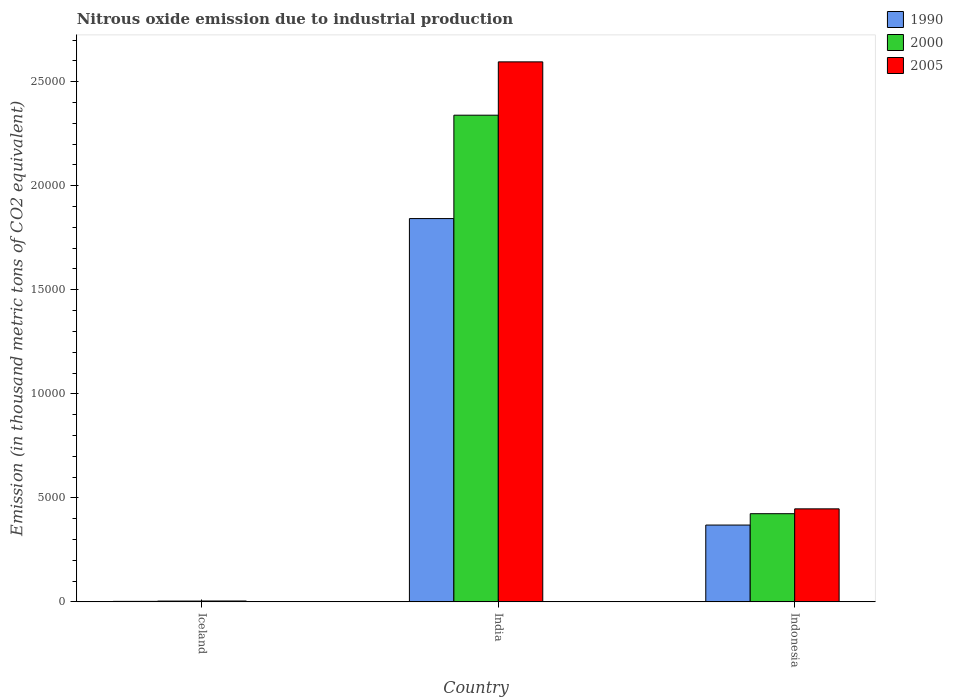How many different coloured bars are there?
Offer a terse response. 3. How many bars are there on the 3rd tick from the right?
Ensure brevity in your answer.  3. What is the amount of nitrous oxide emitted in 2005 in India?
Offer a terse response. 2.60e+04. Across all countries, what is the maximum amount of nitrous oxide emitted in 2000?
Make the answer very short. 2.34e+04. Across all countries, what is the minimum amount of nitrous oxide emitted in 2000?
Keep it short and to the point. 38.6. In which country was the amount of nitrous oxide emitted in 2000 maximum?
Your response must be concise. India. What is the total amount of nitrous oxide emitted in 2005 in the graph?
Offer a very short reply. 3.05e+04. What is the difference between the amount of nitrous oxide emitted in 2005 in Iceland and that in India?
Your response must be concise. -2.59e+04. What is the difference between the amount of nitrous oxide emitted in 2005 in India and the amount of nitrous oxide emitted in 1990 in Indonesia?
Make the answer very short. 2.23e+04. What is the average amount of nitrous oxide emitted in 2000 per country?
Your answer should be very brief. 9222.6. What is the difference between the amount of nitrous oxide emitted of/in 2000 and amount of nitrous oxide emitted of/in 1990 in India?
Keep it short and to the point. 4968.5. In how many countries, is the amount of nitrous oxide emitted in 2005 greater than 2000 thousand metric tons?
Give a very brief answer. 2. What is the ratio of the amount of nitrous oxide emitted in 2005 in Iceland to that in Indonesia?
Ensure brevity in your answer.  0.01. Is the amount of nitrous oxide emitted in 2005 in Iceland less than that in India?
Keep it short and to the point. Yes. What is the difference between the highest and the second highest amount of nitrous oxide emitted in 1990?
Keep it short and to the point. -3667.8. What is the difference between the highest and the lowest amount of nitrous oxide emitted in 1990?
Your answer should be compact. 1.84e+04. What does the 3rd bar from the left in Indonesia represents?
Make the answer very short. 2005. What is the difference between two consecutive major ticks on the Y-axis?
Your answer should be compact. 5000. Does the graph contain any zero values?
Keep it short and to the point. No. Where does the legend appear in the graph?
Give a very brief answer. Top right. What is the title of the graph?
Provide a succinct answer. Nitrous oxide emission due to industrial production. Does "1974" appear as one of the legend labels in the graph?
Provide a short and direct response. No. What is the label or title of the Y-axis?
Keep it short and to the point. Emission (in thousand metric tons of CO2 equivalent). What is the Emission (in thousand metric tons of CO2 equivalent) in 1990 in Iceland?
Ensure brevity in your answer.  24.6. What is the Emission (in thousand metric tons of CO2 equivalent) of 2000 in Iceland?
Ensure brevity in your answer.  38.6. What is the Emission (in thousand metric tons of CO2 equivalent) in 2005 in Iceland?
Ensure brevity in your answer.  42.1. What is the Emission (in thousand metric tons of CO2 equivalent) in 1990 in India?
Ensure brevity in your answer.  1.84e+04. What is the Emission (in thousand metric tons of CO2 equivalent) of 2000 in India?
Your answer should be compact. 2.34e+04. What is the Emission (in thousand metric tons of CO2 equivalent) in 2005 in India?
Offer a very short reply. 2.60e+04. What is the Emission (in thousand metric tons of CO2 equivalent) of 1990 in Indonesia?
Your answer should be compact. 3692.4. What is the Emission (in thousand metric tons of CO2 equivalent) of 2000 in Indonesia?
Ensure brevity in your answer.  4237.9. What is the Emission (in thousand metric tons of CO2 equivalent) in 2005 in Indonesia?
Keep it short and to the point. 4470.7. Across all countries, what is the maximum Emission (in thousand metric tons of CO2 equivalent) of 1990?
Give a very brief answer. 1.84e+04. Across all countries, what is the maximum Emission (in thousand metric tons of CO2 equivalent) in 2000?
Ensure brevity in your answer.  2.34e+04. Across all countries, what is the maximum Emission (in thousand metric tons of CO2 equivalent) of 2005?
Your answer should be compact. 2.60e+04. Across all countries, what is the minimum Emission (in thousand metric tons of CO2 equivalent) in 1990?
Your answer should be compact. 24.6. Across all countries, what is the minimum Emission (in thousand metric tons of CO2 equivalent) in 2000?
Provide a short and direct response. 38.6. Across all countries, what is the minimum Emission (in thousand metric tons of CO2 equivalent) in 2005?
Make the answer very short. 42.1. What is the total Emission (in thousand metric tons of CO2 equivalent) of 1990 in the graph?
Provide a succinct answer. 2.21e+04. What is the total Emission (in thousand metric tons of CO2 equivalent) of 2000 in the graph?
Your answer should be very brief. 2.77e+04. What is the total Emission (in thousand metric tons of CO2 equivalent) of 2005 in the graph?
Your answer should be very brief. 3.05e+04. What is the difference between the Emission (in thousand metric tons of CO2 equivalent) of 1990 in Iceland and that in India?
Offer a terse response. -1.84e+04. What is the difference between the Emission (in thousand metric tons of CO2 equivalent) of 2000 in Iceland and that in India?
Your answer should be very brief. -2.34e+04. What is the difference between the Emission (in thousand metric tons of CO2 equivalent) of 2005 in Iceland and that in India?
Offer a very short reply. -2.59e+04. What is the difference between the Emission (in thousand metric tons of CO2 equivalent) in 1990 in Iceland and that in Indonesia?
Give a very brief answer. -3667.8. What is the difference between the Emission (in thousand metric tons of CO2 equivalent) of 2000 in Iceland and that in Indonesia?
Ensure brevity in your answer.  -4199.3. What is the difference between the Emission (in thousand metric tons of CO2 equivalent) of 2005 in Iceland and that in Indonesia?
Make the answer very short. -4428.6. What is the difference between the Emission (in thousand metric tons of CO2 equivalent) in 1990 in India and that in Indonesia?
Ensure brevity in your answer.  1.47e+04. What is the difference between the Emission (in thousand metric tons of CO2 equivalent) in 2000 in India and that in Indonesia?
Your response must be concise. 1.92e+04. What is the difference between the Emission (in thousand metric tons of CO2 equivalent) of 2005 in India and that in Indonesia?
Keep it short and to the point. 2.15e+04. What is the difference between the Emission (in thousand metric tons of CO2 equivalent) in 1990 in Iceland and the Emission (in thousand metric tons of CO2 equivalent) in 2000 in India?
Offer a terse response. -2.34e+04. What is the difference between the Emission (in thousand metric tons of CO2 equivalent) of 1990 in Iceland and the Emission (in thousand metric tons of CO2 equivalent) of 2005 in India?
Keep it short and to the point. -2.59e+04. What is the difference between the Emission (in thousand metric tons of CO2 equivalent) of 2000 in Iceland and the Emission (in thousand metric tons of CO2 equivalent) of 2005 in India?
Your answer should be compact. -2.59e+04. What is the difference between the Emission (in thousand metric tons of CO2 equivalent) in 1990 in Iceland and the Emission (in thousand metric tons of CO2 equivalent) in 2000 in Indonesia?
Offer a very short reply. -4213.3. What is the difference between the Emission (in thousand metric tons of CO2 equivalent) of 1990 in Iceland and the Emission (in thousand metric tons of CO2 equivalent) of 2005 in Indonesia?
Provide a succinct answer. -4446.1. What is the difference between the Emission (in thousand metric tons of CO2 equivalent) in 2000 in Iceland and the Emission (in thousand metric tons of CO2 equivalent) in 2005 in Indonesia?
Give a very brief answer. -4432.1. What is the difference between the Emission (in thousand metric tons of CO2 equivalent) of 1990 in India and the Emission (in thousand metric tons of CO2 equivalent) of 2000 in Indonesia?
Give a very brief answer. 1.42e+04. What is the difference between the Emission (in thousand metric tons of CO2 equivalent) in 1990 in India and the Emission (in thousand metric tons of CO2 equivalent) in 2005 in Indonesia?
Your response must be concise. 1.40e+04. What is the difference between the Emission (in thousand metric tons of CO2 equivalent) of 2000 in India and the Emission (in thousand metric tons of CO2 equivalent) of 2005 in Indonesia?
Provide a short and direct response. 1.89e+04. What is the average Emission (in thousand metric tons of CO2 equivalent) of 1990 per country?
Provide a short and direct response. 7379.93. What is the average Emission (in thousand metric tons of CO2 equivalent) of 2000 per country?
Make the answer very short. 9222.6. What is the average Emission (in thousand metric tons of CO2 equivalent) of 2005 per country?
Your answer should be very brief. 1.02e+04. What is the difference between the Emission (in thousand metric tons of CO2 equivalent) of 1990 and Emission (in thousand metric tons of CO2 equivalent) of 2000 in Iceland?
Your answer should be compact. -14. What is the difference between the Emission (in thousand metric tons of CO2 equivalent) of 1990 and Emission (in thousand metric tons of CO2 equivalent) of 2005 in Iceland?
Provide a succinct answer. -17.5. What is the difference between the Emission (in thousand metric tons of CO2 equivalent) of 1990 and Emission (in thousand metric tons of CO2 equivalent) of 2000 in India?
Your answer should be very brief. -4968.5. What is the difference between the Emission (in thousand metric tons of CO2 equivalent) in 1990 and Emission (in thousand metric tons of CO2 equivalent) in 2005 in India?
Offer a terse response. -7531.6. What is the difference between the Emission (in thousand metric tons of CO2 equivalent) of 2000 and Emission (in thousand metric tons of CO2 equivalent) of 2005 in India?
Your answer should be compact. -2563.1. What is the difference between the Emission (in thousand metric tons of CO2 equivalent) of 1990 and Emission (in thousand metric tons of CO2 equivalent) of 2000 in Indonesia?
Your answer should be very brief. -545.5. What is the difference between the Emission (in thousand metric tons of CO2 equivalent) of 1990 and Emission (in thousand metric tons of CO2 equivalent) of 2005 in Indonesia?
Your response must be concise. -778.3. What is the difference between the Emission (in thousand metric tons of CO2 equivalent) in 2000 and Emission (in thousand metric tons of CO2 equivalent) in 2005 in Indonesia?
Your answer should be very brief. -232.8. What is the ratio of the Emission (in thousand metric tons of CO2 equivalent) in 1990 in Iceland to that in India?
Provide a succinct answer. 0. What is the ratio of the Emission (in thousand metric tons of CO2 equivalent) of 2000 in Iceland to that in India?
Offer a terse response. 0. What is the ratio of the Emission (in thousand metric tons of CO2 equivalent) of 2005 in Iceland to that in India?
Keep it short and to the point. 0. What is the ratio of the Emission (in thousand metric tons of CO2 equivalent) in 1990 in Iceland to that in Indonesia?
Keep it short and to the point. 0.01. What is the ratio of the Emission (in thousand metric tons of CO2 equivalent) of 2000 in Iceland to that in Indonesia?
Your answer should be compact. 0.01. What is the ratio of the Emission (in thousand metric tons of CO2 equivalent) of 2005 in Iceland to that in Indonesia?
Provide a short and direct response. 0.01. What is the ratio of the Emission (in thousand metric tons of CO2 equivalent) of 1990 in India to that in Indonesia?
Offer a terse response. 4.99. What is the ratio of the Emission (in thousand metric tons of CO2 equivalent) of 2000 in India to that in Indonesia?
Offer a very short reply. 5.52. What is the ratio of the Emission (in thousand metric tons of CO2 equivalent) of 2005 in India to that in Indonesia?
Offer a terse response. 5.81. What is the difference between the highest and the second highest Emission (in thousand metric tons of CO2 equivalent) of 1990?
Offer a very short reply. 1.47e+04. What is the difference between the highest and the second highest Emission (in thousand metric tons of CO2 equivalent) in 2000?
Your answer should be very brief. 1.92e+04. What is the difference between the highest and the second highest Emission (in thousand metric tons of CO2 equivalent) in 2005?
Make the answer very short. 2.15e+04. What is the difference between the highest and the lowest Emission (in thousand metric tons of CO2 equivalent) of 1990?
Offer a terse response. 1.84e+04. What is the difference between the highest and the lowest Emission (in thousand metric tons of CO2 equivalent) of 2000?
Your response must be concise. 2.34e+04. What is the difference between the highest and the lowest Emission (in thousand metric tons of CO2 equivalent) in 2005?
Offer a very short reply. 2.59e+04. 